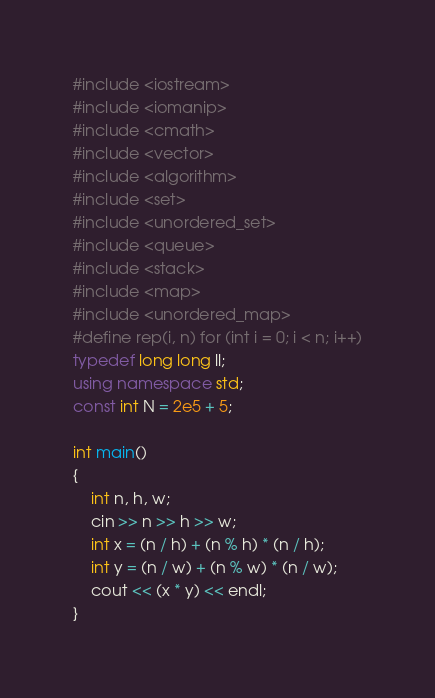Convert code to text. <code><loc_0><loc_0><loc_500><loc_500><_C++_>#include <iostream>
#include <iomanip>
#include <cmath>
#include <vector>
#include <algorithm>
#include <set>
#include <unordered_set>
#include <queue>
#include <stack>
#include <map>
#include <unordered_map>
#define rep(i, n) for (int i = 0; i < n; i++)
typedef long long ll;
using namespace std;
const int N = 2e5 + 5;

int main()
{
    int n, h, w;
    cin >> n >> h >> w;
    int x = (n / h) + (n % h) * (n / h);
    int y = (n / w) + (n % w) * (n / w);
    cout << (x * y) << endl;
}
</code> 